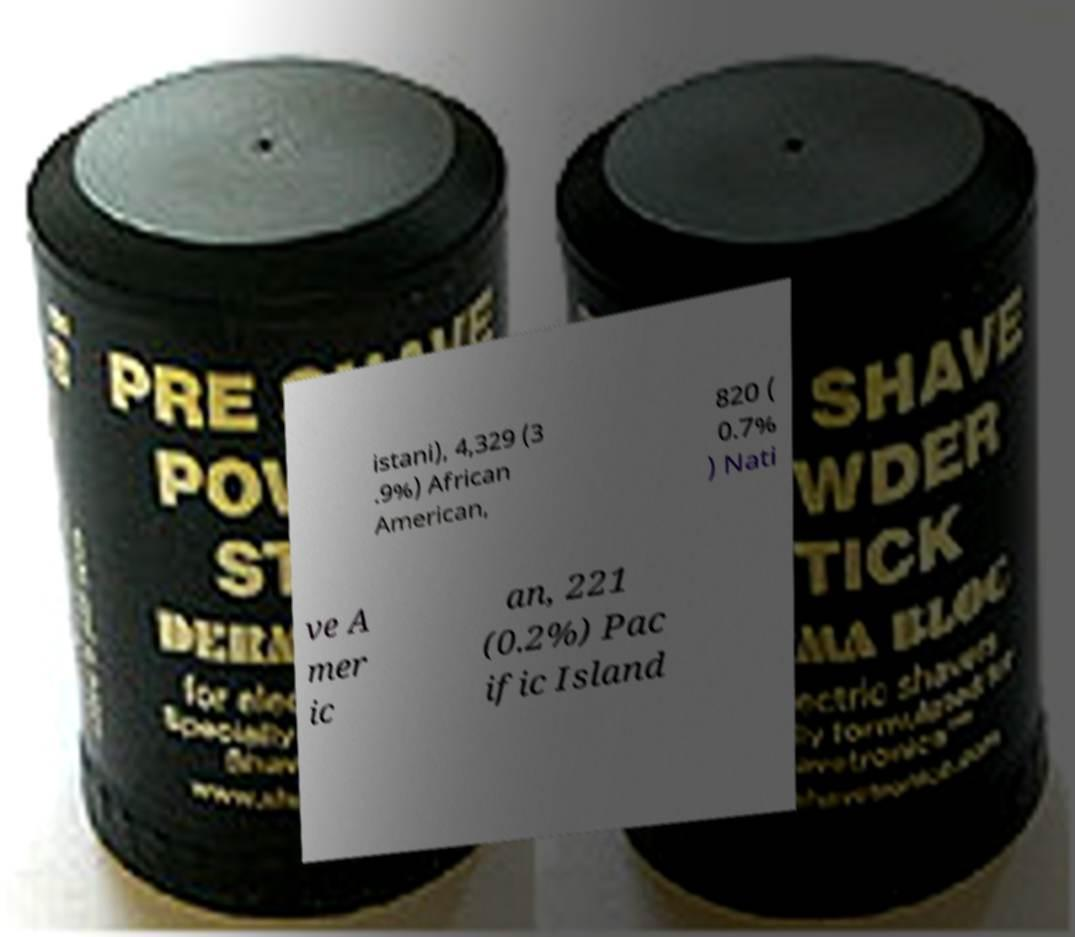Can you read and provide the text displayed in the image?This photo seems to have some interesting text. Can you extract and type it out for me? istani), 4,329 (3 .9%) African American, 820 ( 0.7% ) Nati ve A mer ic an, 221 (0.2%) Pac ific Island 